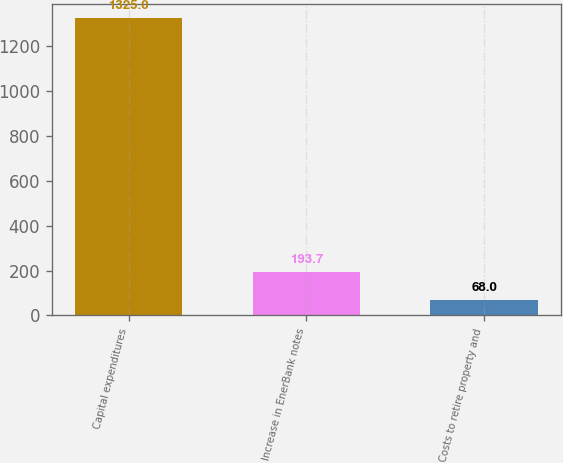Convert chart. <chart><loc_0><loc_0><loc_500><loc_500><bar_chart><fcel>Capital expenditures<fcel>Increase in EnerBank notes<fcel>Costs to retire property and<nl><fcel>1325<fcel>193.7<fcel>68<nl></chart> 